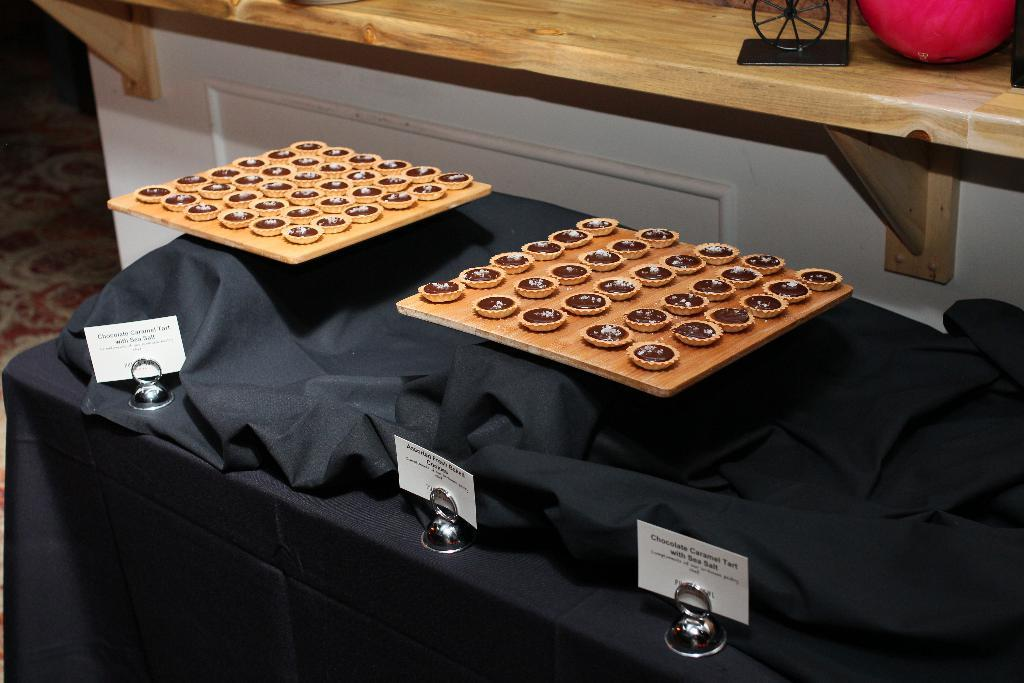What is placed on the wooden plates in the image? There are food items on wooden plates in the image. What can be seen on the table in the image? There are name boards on the table in the image. What is visible in the background of the image? There are objects on a cabinet and a carpet in the background of the image. What type of form is being filled out on the page in the image? There is no page or form present in the image. Can you describe the kettle on the cabinet in the image? There is no kettle visible in the image; only objects on a cabinet are mentioned. 